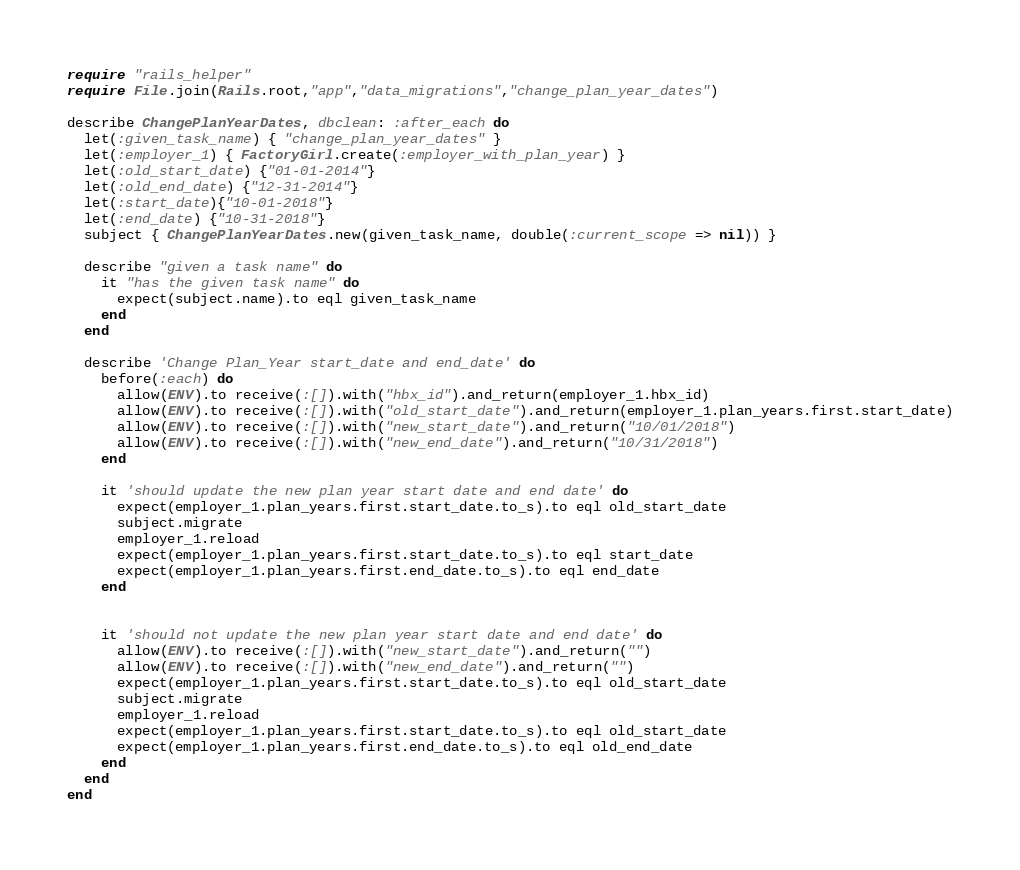Convert code to text. <code><loc_0><loc_0><loc_500><loc_500><_Ruby_>require "rails_helper"
require File.join(Rails.root,"app","data_migrations","change_plan_year_dates")

describe ChangePlanYearDates, dbclean: :after_each do
  let(:given_task_name) { "change_plan_year_dates" }
  let(:employer_1) { FactoryGirl.create(:employer_with_plan_year) }
  let(:old_start_date) {"01-01-2014"}
  let(:old_end_date) {"12-31-2014"}
  let(:start_date){"10-01-2018"}
  let(:end_date) {"10-31-2018"}
  subject { ChangePlanYearDates.new(given_task_name, double(:current_scope => nil)) }

  describe "given a task name" do 
    it "has the given task name" do 
      expect(subject.name).to eql given_task_name
    end
  end

  describe 'Change Plan_Year start_date and end_date' do 
    before(:each) do 
      allow(ENV).to receive(:[]).with("hbx_id").and_return(employer_1.hbx_id)
      allow(ENV).to receive(:[]).with("old_start_date").and_return(employer_1.plan_years.first.start_date)
      allow(ENV).to receive(:[]).with("new_start_date").and_return("10/01/2018")
      allow(ENV).to receive(:[]).with("new_end_date").and_return("10/31/2018")
    end

    it 'should update the new plan year start date and end date' do 
      expect(employer_1.plan_years.first.start_date.to_s).to eql old_start_date
      subject.migrate
      employer_1.reload
      expect(employer_1.plan_years.first.start_date.to_s).to eql start_date
      expect(employer_1.plan_years.first.end_date.to_s).to eql end_date
    end


    it 'should not update the new plan year start date and end date' do
      allow(ENV).to receive(:[]).with("new_start_date").and_return("")
      allow(ENV).to receive(:[]).with("new_end_date").and_return("")
      expect(employer_1.plan_years.first.start_date.to_s).to eql old_start_date
      subject.migrate
      employer_1.reload
      expect(employer_1.plan_years.first.start_date.to_s).to eql old_start_date
      expect(employer_1.plan_years.first.end_date.to_s).to eql old_end_date
    end
  end
end
</code> 